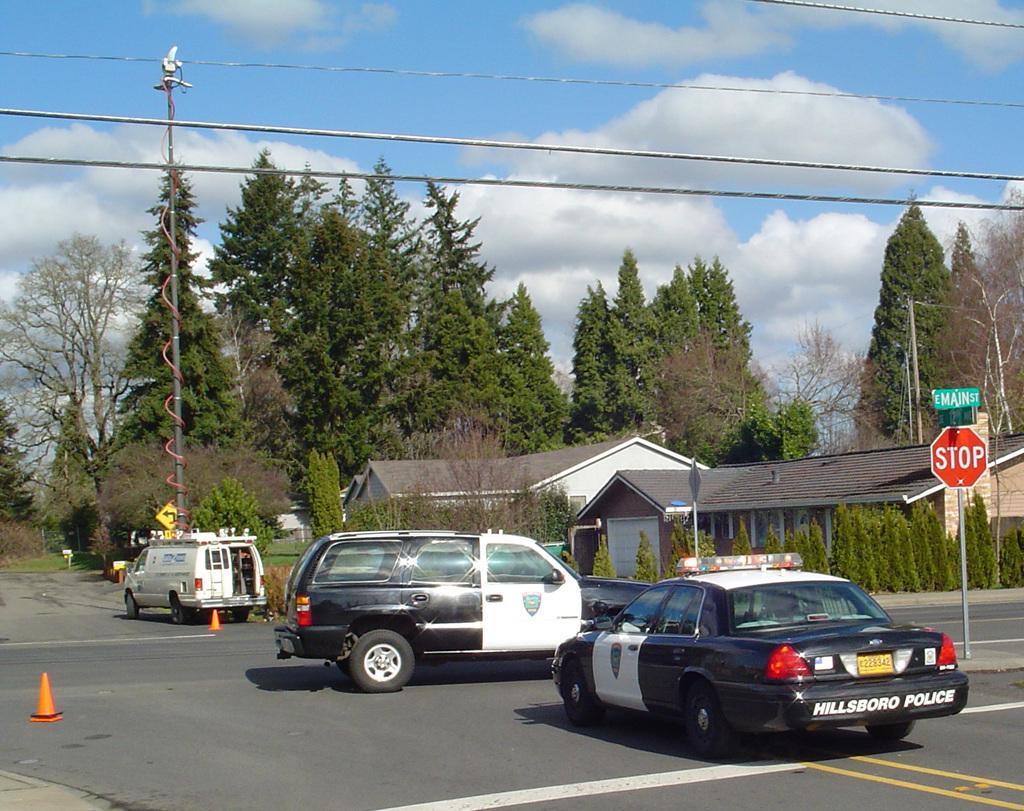Can you describe this image briefly? In this image I can see the vehicles on the road. I can also see the traffic cones on the road. To the side of the road there are boards, poles, many trees and the houses. In the background I can see the clouds and the blue sky. 